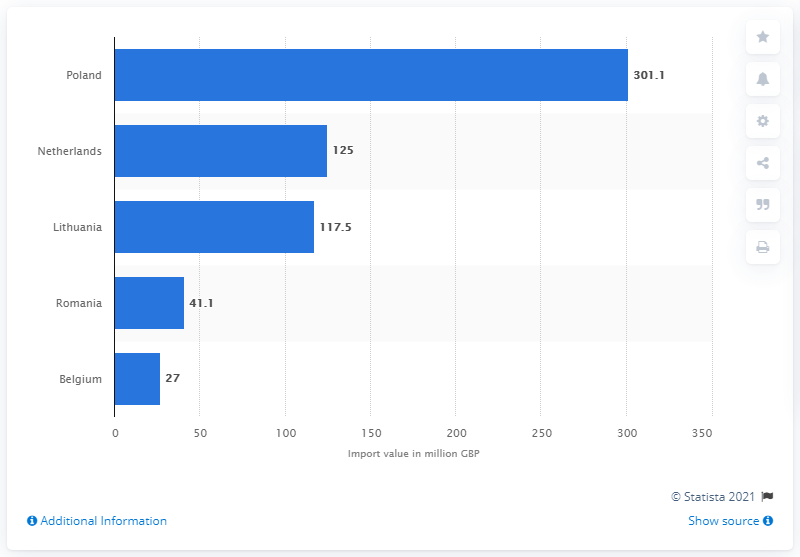Outline some significant characteristics in this image. The biggest country of origin for tobacco imported into the UK was Poland. 